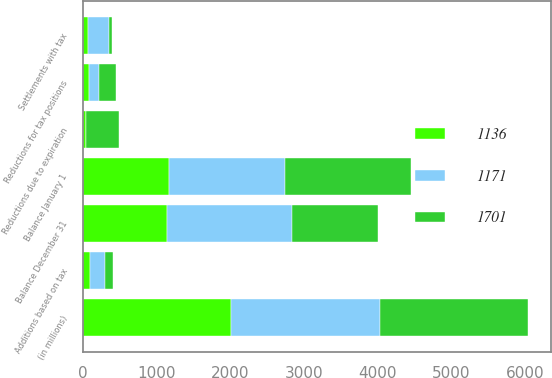Convert chart to OTSL. <chart><loc_0><loc_0><loc_500><loc_500><stacked_bar_chart><ecel><fcel>(in millions)<fcel>Balance January 1<fcel>Additions based on tax<fcel>Reductions for tax positions<fcel>Reductions due to expiration<fcel>Settlements with tax<fcel>Balance December 31<nl><fcel>1136<fcel>2015<fcel>1171<fcel>98<fcel>84<fcel>41<fcel>75<fcel>1136<nl><fcel>1701<fcel>2014<fcel>1701<fcel>111<fcel>220<fcel>448<fcel>36<fcel>1171<nl><fcel>1171<fcel>2013<fcel>1573<fcel>201<fcel>141<fcel>3<fcel>287<fcel>1701<nl></chart> 